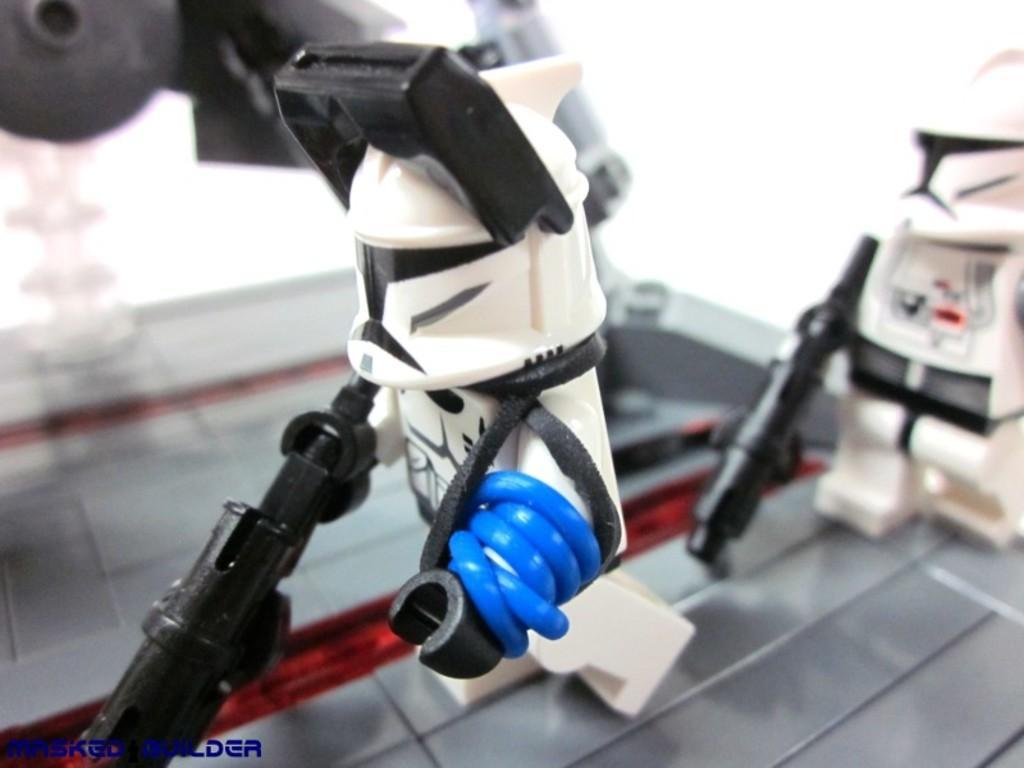How would you summarize this image in a sentence or two? In this image there is a small robot toy in the middle. In the background there is another small robot which is holding the gun. 